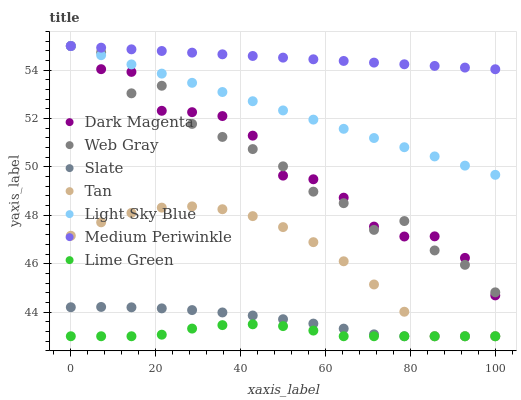Does Lime Green have the minimum area under the curve?
Answer yes or no. Yes. Does Medium Periwinkle have the maximum area under the curve?
Answer yes or no. Yes. Does Dark Magenta have the minimum area under the curve?
Answer yes or no. No. Does Dark Magenta have the maximum area under the curve?
Answer yes or no. No. Is Medium Periwinkle the smoothest?
Answer yes or no. Yes. Is Web Gray the roughest?
Answer yes or no. Yes. Is Dark Magenta the smoothest?
Answer yes or no. No. Is Dark Magenta the roughest?
Answer yes or no. No. Does Slate have the lowest value?
Answer yes or no. Yes. Does Dark Magenta have the lowest value?
Answer yes or no. No. Does Light Sky Blue have the highest value?
Answer yes or no. Yes. Does Slate have the highest value?
Answer yes or no. No. Is Slate less than Dark Magenta?
Answer yes or no. Yes. Is Medium Periwinkle greater than Lime Green?
Answer yes or no. Yes. Does Medium Periwinkle intersect Web Gray?
Answer yes or no. Yes. Is Medium Periwinkle less than Web Gray?
Answer yes or no. No. Is Medium Periwinkle greater than Web Gray?
Answer yes or no. No. Does Slate intersect Dark Magenta?
Answer yes or no. No. 